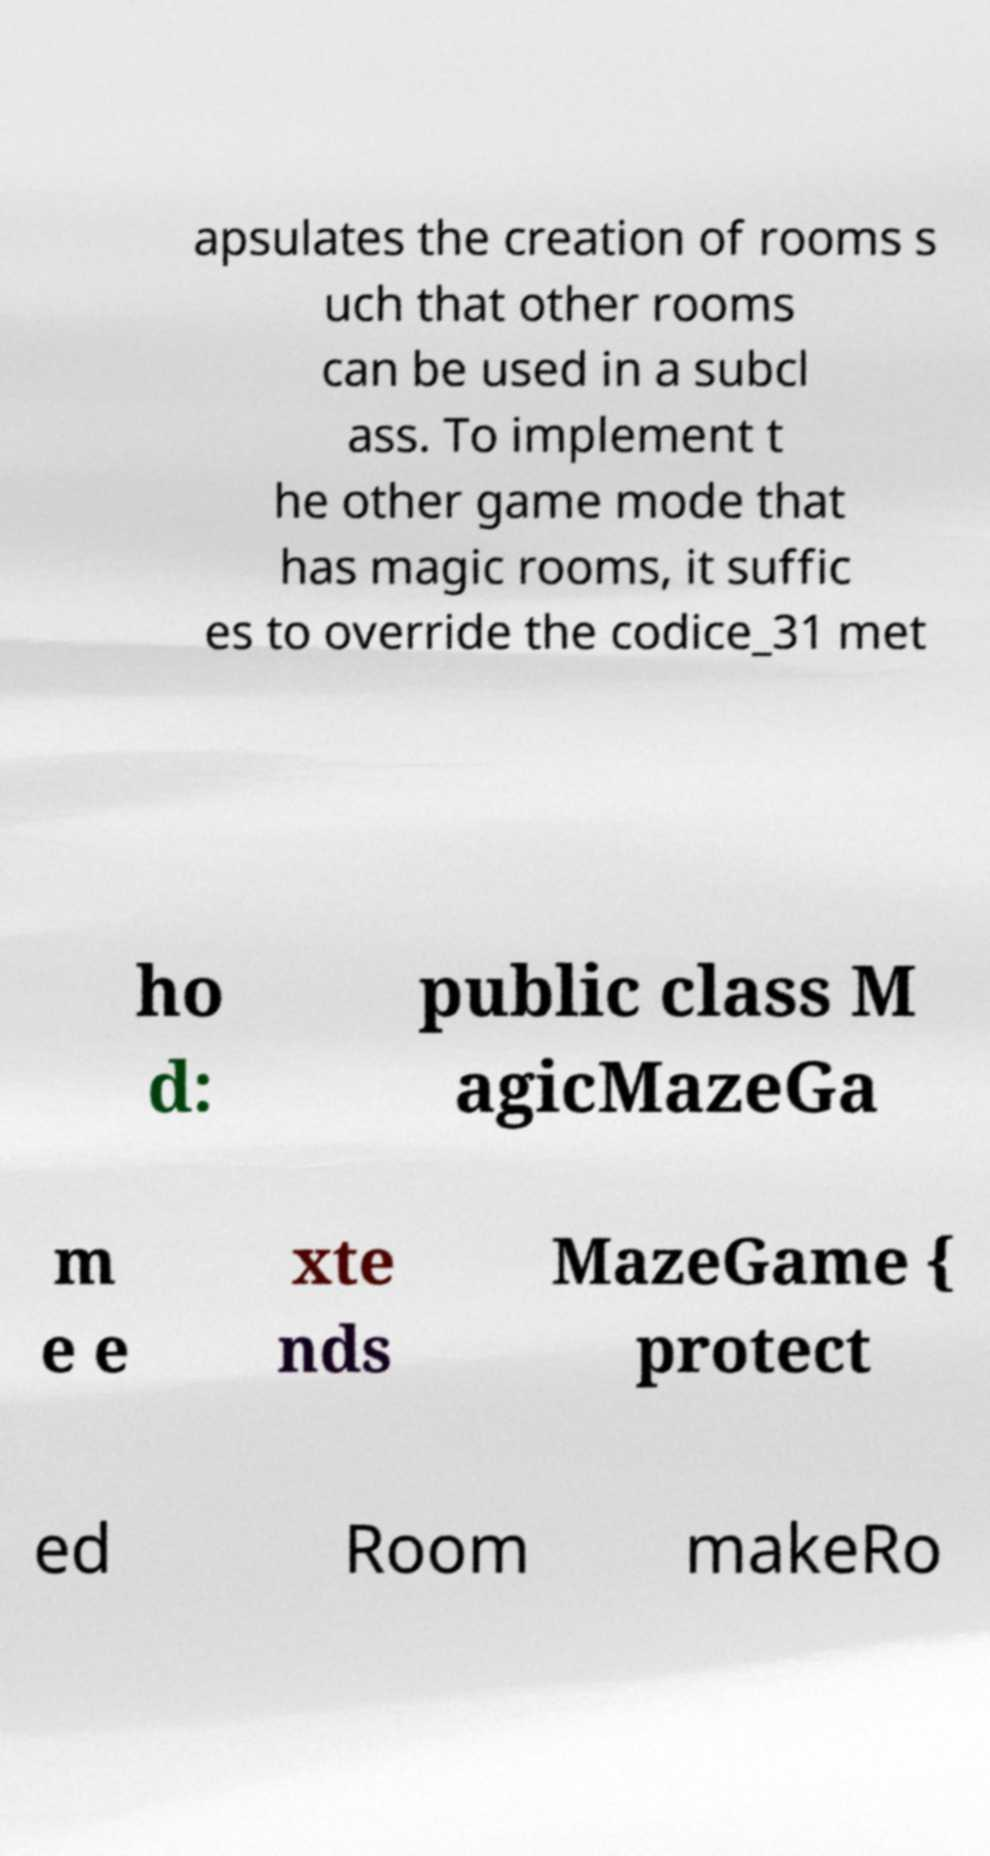Could you extract and type out the text from this image? apsulates the creation of rooms s uch that other rooms can be used in a subcl ass. To implement t he other game mode that has magic rooms, it suffic es to override the codice_31 met ho d: public class M agicMazeGa m e e xte nds MazeGame { protect ed Room makeRo 